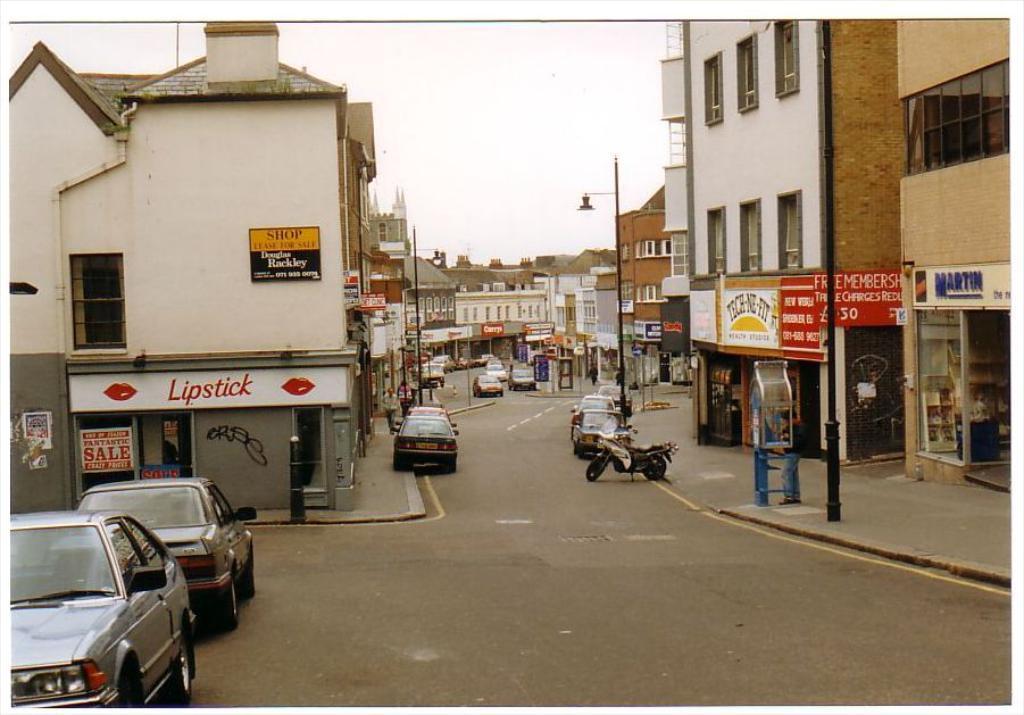How would you summarize this image in a sentence or two? In the foreground of this image, there are vehicles on the road. On either side, there buildings, poles, boards and at the top, there is the sky. 